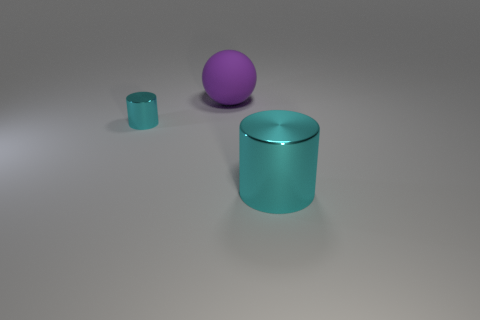How does the size of the small cyan cylinder compare to the large purple sphere? The small cyan cylinder is considerably smaller in size compared to the large purple sphere, both in height and diameter. 